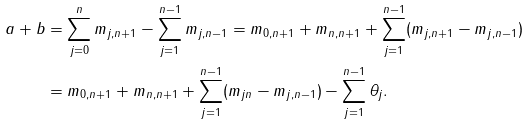<formula> <loc_0><loc_0><loc_500><loc_500>a + b & = \sum _ { j = 0 } ^ { n } m _ { j , n + 1 } - \sum _ { j = 1 } ^ { n - 1 } m _ { j , n - 1 } = m _ { 0 , n + 1 } + m _ { n , n + 1 } + \sum _ { j = 1 } ^ { n - 1 } ( m _ { j , n + 1 } - m _ { j , n - 1 } ) \\ & = m _ { 0 , n + 1 } + m _ { n , n + 1 } + \sum _ { j = 1 } ^ { n - 1 } ( m _ { j n } - m _ { j , n - 1 } ) - \sum _ { j = 1 } ^ { n - 1 } \theta _ { j } .</formula> 